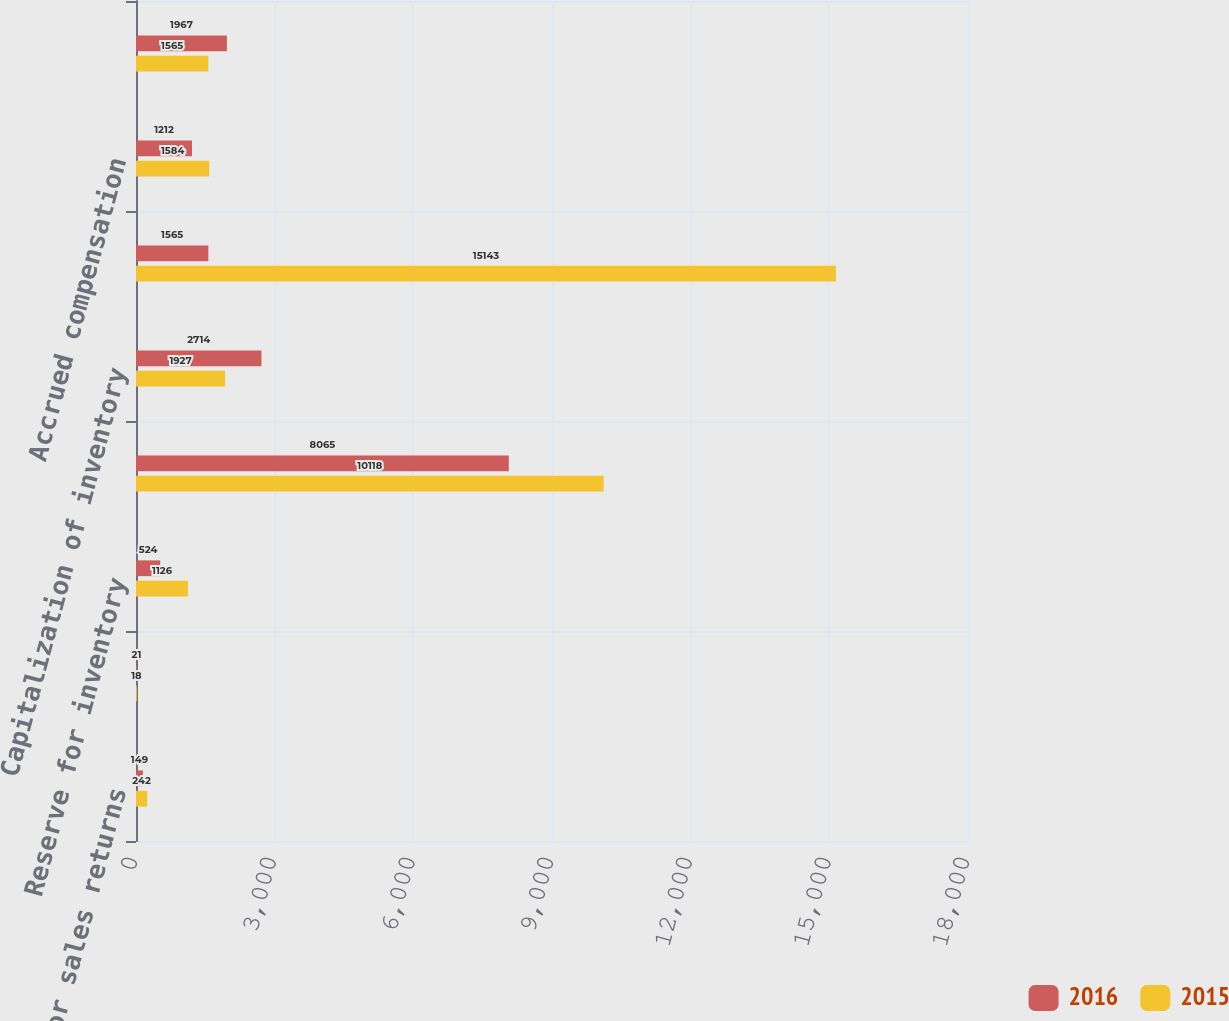Convert chart to OTSL. <chart><loc_0><loc_0><loc_500><loc_500><stacked_bar_chart><ecel><fcel>Reserve for sales returns<fcel>Reserve for doubtful accounts<fcel>Reserve for inventory<fcel>Reserve for marketing<fcel>Capitalization of inventory<fcel>State franchise tax - current<fcel>Accrued compensation<fcel>Accrued other liabilities<nl><fcel>2016<fcel>149<fcel>21<fcel>524<fcel>8065<fcel>2714<fcel>1565<fcel>1212<fcel>1967<nl><fcel>2015<fcel>242<fcel>18<fcel>1126<fcel>10118<fcel>1927<fcel>15143<fcel>1584<fcel>1565<nl></chart> 